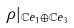<formula> <loc_0><loc_0><loc_500><loc_500>\rho | _ { \mathbb { C } e _ { 1 } \oplus \mathbb { C } e _ { 3 } }</formula> 